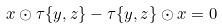<formula> <loc_0><loc_0><loc_500><loc_500>x \odot \tau \{ y , z \} - \tau \{ y , z \} \odot x = 0</formula> 